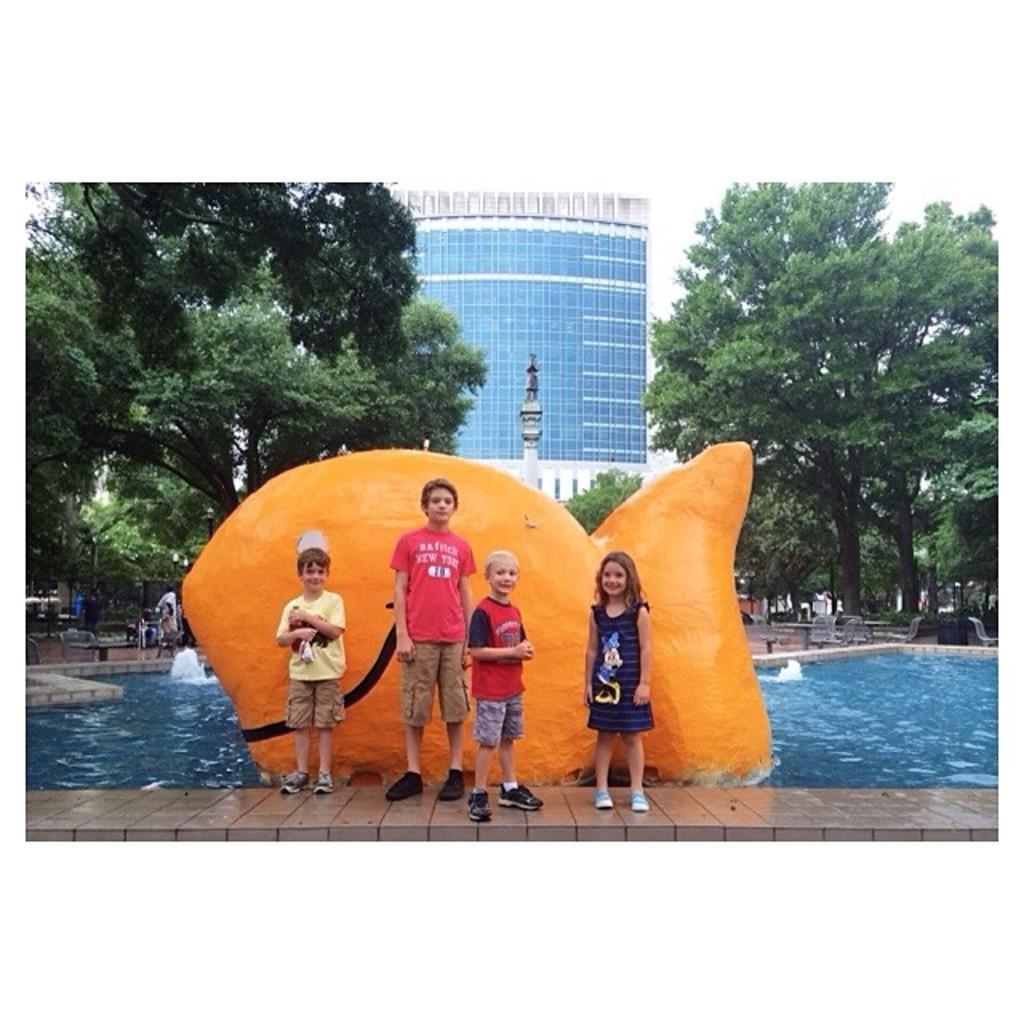Can you describe this image briefly? In the center of the image we can see children standing. In the background there is a sculpture and trees. At the bottom there is swimming pool and we can see a building. 